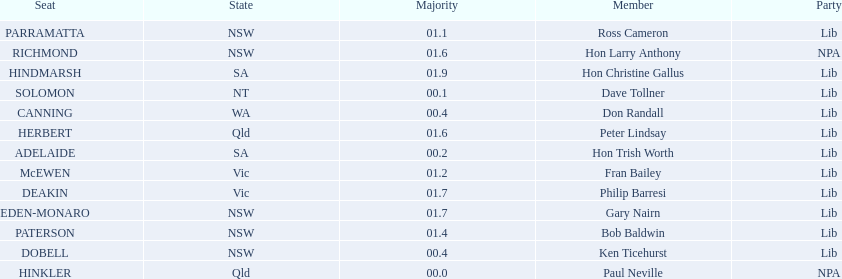What is the difference in majority between hindmarsh and hinkler? 01.9. 